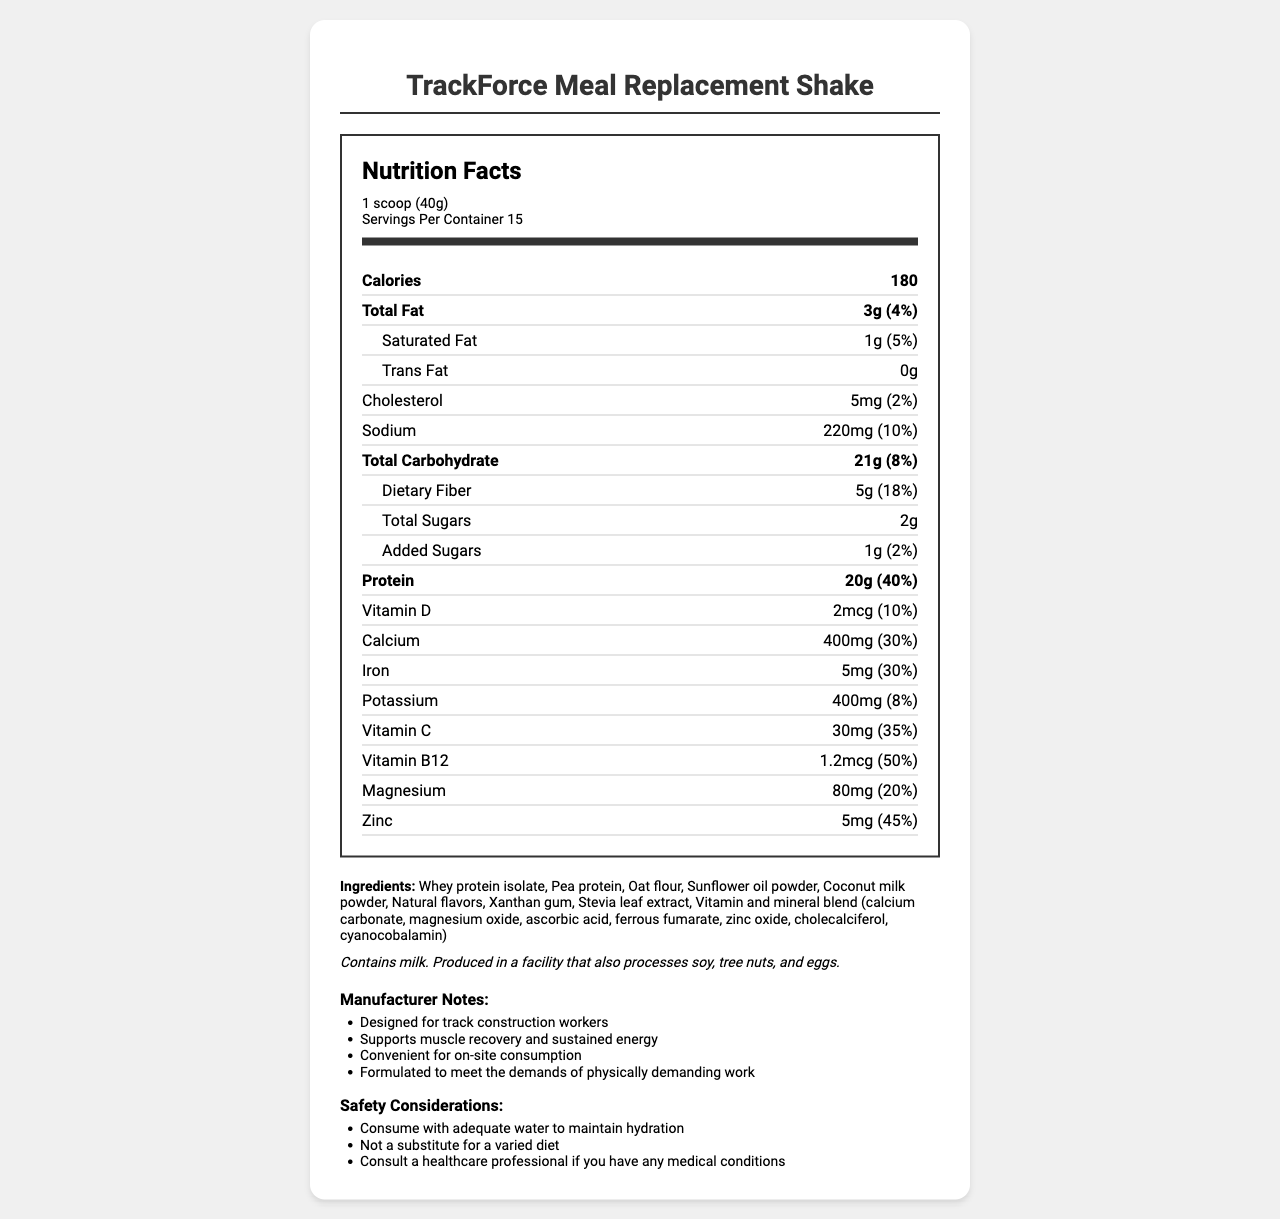what is the serving size of TrackForce Meal Replacement Shake? The serving size is clearly mentioned on the label.
Answer: 1 scoop (40g) how many servings are there per container? As indicated by the "Servings Per Container" section of the label, there are 15 servings per container.
Answer: 15 what is the total amount of protein per serving? The label states that each serving contains 20 grams of protein.
Answer: 20g how much calcium does each serving provide? Each serving provides 400 milligrams of calcium, as listed under the "Calcium" section.
Answer: 400mg how much dietary fiber is in each serving? The "Dietary Fiber" section of the label indicates that there are 5 grams of dietary fiber per serving.
Answer: 5g which of the following vitamins has the highest daily value percentage? A. Vitamin D B. Vitamin C C. Vitamin B12 The label shows that Vitamin B12 has a daily value percentage of 50%, which is higher than the 10% for Vitamin D and 35% for Vitamin C.
Answer: C. Vitamin B12 how many grams of total fat does each serving contain? A. 1g B. 3g C. 5g The "Total Fat" section on the label indicates that each serving contains 3 grams of total fat.
Answer: B. 3g is the product suitable for vegans? The allergen information states that the product contains milk, which is not suitable for a vegan diet.
Answer: No what should consumers do to maintain hydration while consuming this product? The safety considerations recommend consuming the product with adequate water to maintain hydration.
Answer: Consume with adequate water what are the main sources of protein in this product? The ingredients list reveals that the main sources of protein are whey protein isolate and pea protein.
Answer: Whey protein isolate, Pea protein how many mg of sodium are there per serving? Each serving contains 220 milligrams of sodium as shown on the label.
Answer: 220mg list two safety considerations mentioned for consuming this product These considerations are listed under the "Safety Considerations" section of the document.
Answer: Consume with adequate water to maintain hydration, Not a substitute for a varied diet what is the percentage of daily value for iron per serving? The "Iron" section of the label indicates that each serving provides 30% of the daily value.
Answer: 30% does the product contain any added sugars? The label indicates that there is 1 gram of added sugars per serving.
Answer: Yes describe the main idea of the document This detailed explanation covers the structure and content of the document.
Answer: The document provides detailed nutritional information about the TrackForce Meal Replacement Shake, including serving size, calories, macronutrients, vitamins, minerals, ingredients, allergen information, manufacturer notes, and safety considerations. what is the source of Vitamin B12 in the product? The label doesn't specify the exact source of Vitamin B12 used in the product.
Answer: Not enough information what is the manufacturer's goal in formulating this shake? The manufacturer notes indicate that the product is designed to support muscle recovery and sustained energy for physically demanding work.
Answer: Supports muscle recovery and sustained energy does the product contain gluten? The allergen information does not mention gluten, but it is not explicitly stated whether the product contains gluten or not.
Answer: I don't know 